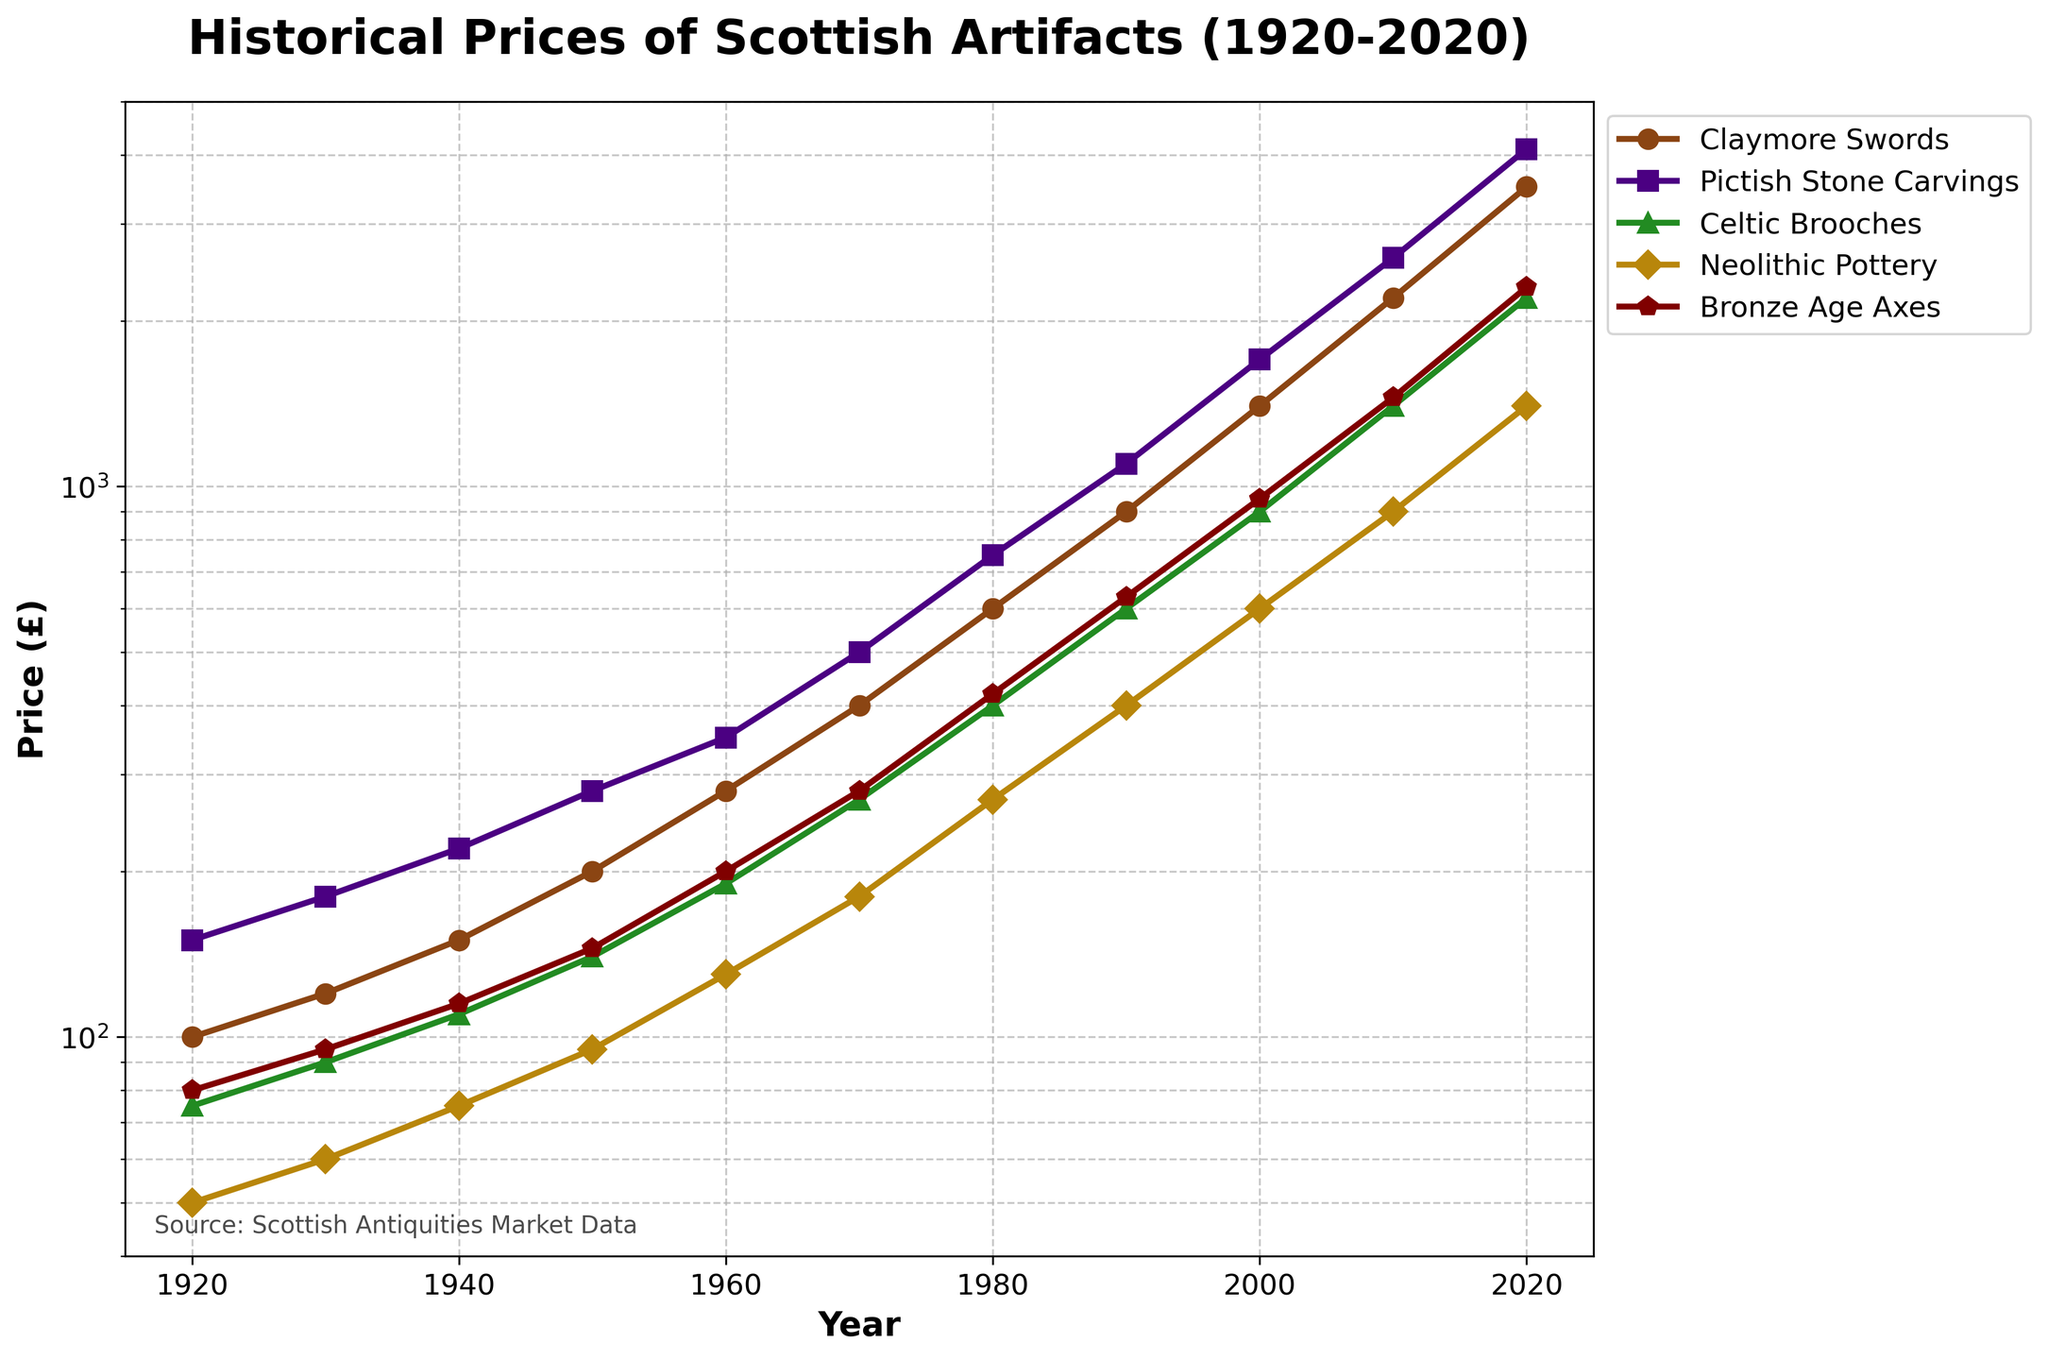What is the approximate price of a Claymore Sword in 1980? Locate the point on the Claymore Swords line corresponding to the year 1980 on the x-axis and read the price on the y-axis.
Answer: 600 By how much did the price of Bronze Age Axes increase from 1920 to 2020? Identify the prices of Bronze Age Axes in 1920 and 2020, then subtract the former from the latter: 2300 - 80.
Answer: 2220 Which artifact type had the highest price in 2020? Compare the endpoints of the lines for all artifact types at 2020 on the x-axis and find the one with the highest value on the y-axis.
Answer: Pictish Stone Carvings What is the difference between the prices of Celtic Brooches and Neolithic Pottery in 2010? Find and subtract the price of Neolithic Pottery from the price of Celtic Brooches in 2010: 1400 - 900.
Answer: 500 Which artifact had the steepest increase in price between 1960 and 2000? Calculate the price increase for each artifact from 1960 to 2000 and compare: 
Claymore Swords: 1400 - 280, 
Pictish Stone Carvings: 1700 - 350, 
Celtic Brooches: 900 - 190, 
Neolithic Pottery: 600 - 130, 
Bronze Age Axes: 950 - 200. 
The largest increase is for Claymore Swords: 1120.
Answer: Claymore Swords What is the average price of Claymore Swords across all years? Sum the prices of Claymore Swords for all years and divide by the number of data points: 
(100 + 120 + 150 + 200 + 280 + 400 + 600 + 900 + 1400 + 2200 + 3500) 
= 9850, 9850 / 11.
Answer: 895.5 In which decade did Pictish Stone Carvings see the most significant increase? Compare the price increases of Pictish Stone Carvings for each decade: 150 to 180, 180 to 220, 220 to 280... The decade with the largest increase is from 2010 to 2020: 4100 - 2600.
Answer: 2010-2020 What is the combined price of Neolithic Pottery and Bronze Age Axes in 1950? Find the prices of Neolithic Pottery and Bronze Age Axes in 1950 and sum them: 95 + 145.
Answer: 240 What is the trend observed for Celtic Brooches between 1920 and 2020? Identify the starting and ending points of the Celtic Brooches line: the price increases steadily over time from 75 to 2200.
Answer: Steady increase Compare the growth rates of Pictish Stone Carvings and Neolithic Pottery from 1920 to 2020. Calculate the growth for each: 
Pictish Stone Carvings: (4100 - 150) / 150, 
Neolithic Pottery: (1400 - 50) / 50. 
Compare the growth rates: the growth rate of Pictish Stone Carvings is higher.
Answer: Pictish Stone Carvings 